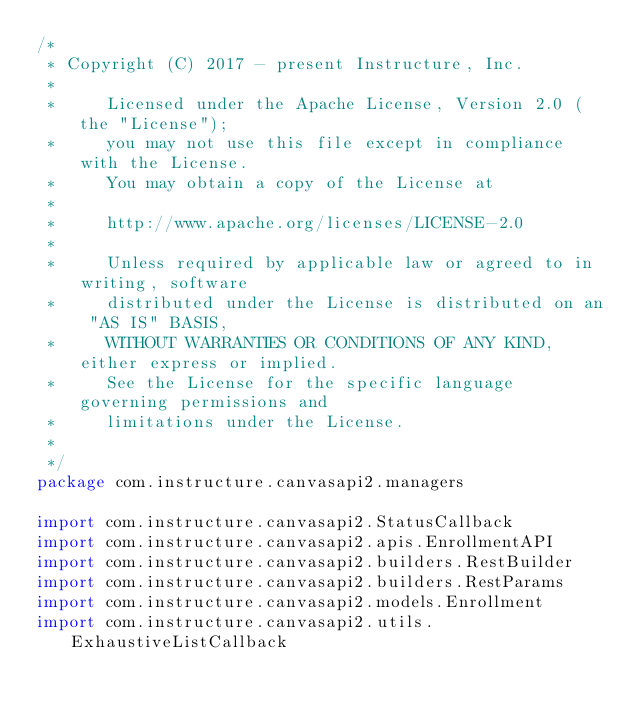<code> <loc_0><loc_0><loc_500><loc_500><_Kotlin_>/*
 * Copyright (C) 2017 - present Instructure, Inc.
 *
 *     Licensed under the Apache License, Version 2.0 (the "License");
 *     you may not use this file except in compliance with the License.
 *     You may obtain a copy of the License at
 *
 *     http://www.apache.org/licenses/LICENSE-2.0
 *
 *     Unless required by applicable law or agreed to in writing, software
 *     distributed under the License is distributed on an "AS IS" BASIS,
 *     WITHOUT WARRANTIES OR CONDITIONS OF ANY KIND, either express or implied.
 *     See the License for the specific language governing permissions and
 *     limitations under the License.
 *
 */
package com.instructure.canvasapi2.managers

import com.instructure.canvasapi2.StatusCallback
import com.instructure.canvasapi2.apis.EnrollmentAPI
import com.instructure.canvasapi2.builders.RestBuilder
import com.instructure.canvasapi2.builders.RestParams
import com.instructure.canvasapi2.models.Enrollment
import com.instructure.canvasapi2.utils.ExhaustiveListCallback</code> 